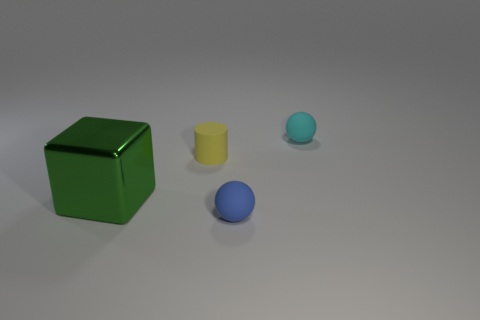Add 1 tiny yellow objects. How many objects exist? 5 Subtract 1 cylinders. How many cylinders are left? 0 Subtract all green balls. How many green cylinders are left? 0 Subtract all big shiny blocks. Subtract all small cyan rubber balls. How many objects are left? 2 Add 2 small blue matte objects. How many small blue matte objects are left? 3 Add 2 tiny blue matte spheres. How many tiny blue matte spheres exist? 3 Subtract 0 gray balls. How many objects are left? 4 Subtract all cylinders. How many objects are left? 3 Subtract all blue spheres. Subtract all brown cylinders. How many spheres are left? 1 